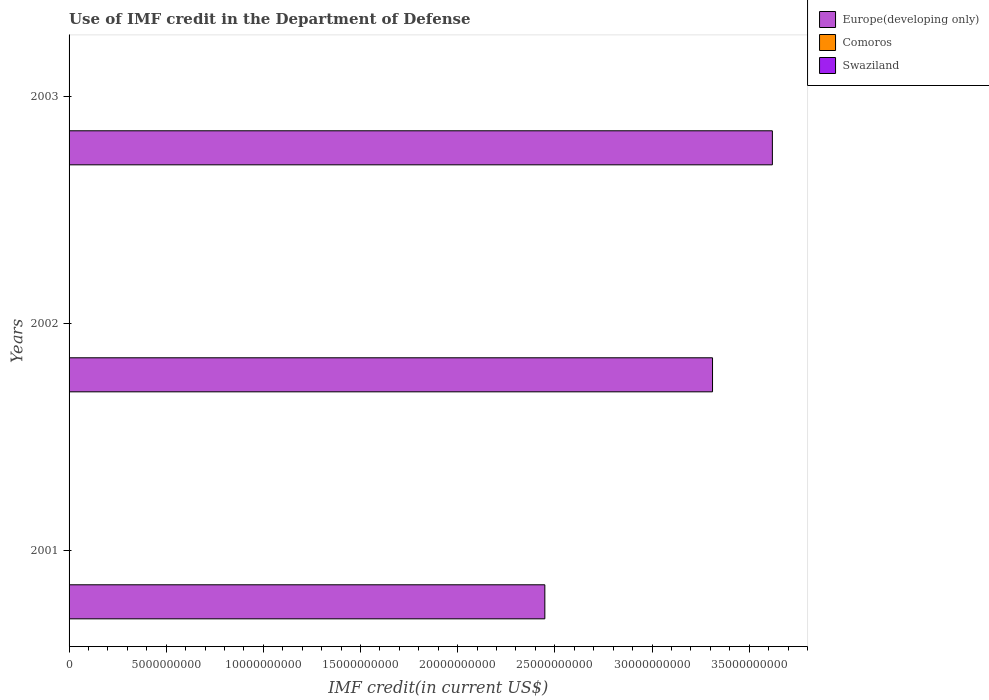How many different coloured bars are there?
Ensure brevity in your answer.  3. Are the number of bars per tick equal to the number of legend labels?
Give a very brief answer. Yes. How many bars are there on the 1st tick from the bottom?
Your answer should be compact. 3. In how many cases, is the number of bars for a given year not equal to the number of legend labels?
Keep it short and to the point. 0. What is the IMF credit in the Department of Defense in Comoros in 2002?
Your answer should be compact. 1.52e+06. Across all years, what is the maximum IMF credit in the Department of Defense in Swaziland?
Give a very brief answer. 9.56e+06. Across all years, what is the minimum IMF credit in the Department of Defense in Swaziland?
Offer a terse response. 8.08e+06. In which year was the IMF credit in the Department of Defense in Europe(developing only) maximum?
Provide a short and direct response. 2003. What is the total IMF credit in the Department of Defense in Europe(developing only) in the graph?
Your response must be concise. 9.38e+1. What is the difference between the IMF credit in the Department of Defense in Europe(developing only) in 2001 and that in 2003?
Offer a terse response. -1.17e+1. What is the difference between the IMF credit in the Department of Defense in Swaziland in 2001 and the IMF credit in the Department of Defense in Europe(developing only) in 2002?
Your answer should be compact. -3.31e+1. What is the average IMF credit in the Department of Defense in Swaziland per year?
Your answer should be very brief. 8.80e+06. In the year 2003, what is the difference between the IMF credit in the Department of Defense in Swaziland and IMF credit in the Department of Defense in Europe(developing only)?
Ensure brevity in your answer.  -3.62e+1. What is the ratio of the IMF credit in the Department of Defense in Europe(developing only) in 2002 to that in 2003?
Provide a short and direct response. 0.91. Is the IMF credit in the Department of Defense in Europe(developing only) in 2001 less than that in 2002?
Your response must be concise. Yes. What is the difference between the highest and the second highest IMF credit in the Department of Defense in Europe(developing only)?
Give a very brief answer. 3.08e+09. What is the difference between the highest and the lowest IMF credit in the Department of Defense in Swaziland?
Your response must be concise. 1.48e+06. What does the 3rd bar from the top in 2003 represents?
Your response must be concise. Europe(developing only). What does the 3rd bar from the bottom in 2001 represents?
Your response must be concise. Swaziland. Is it the case that in every year, the sum of the IMF credit in the Department of Defense in Comoros and IMF credit in the Department of Defense in Swaziland is greater than the IMF credit in the Department of Defense in Europe(developing only)?
Give a very brief answer. No. Are all the bars in the graph horizontal?
Keep it short and to the point. Yes. Are the values on the major ticks of X-axis written in scientific E-notation?
Keep it short and to the point. No. Does the graph contain any zero values?
Ensure brevity in your answer.  No. Does the graph contain grids?
Offer a very short reply. No. Where does the legend appear in the graph?
Offer a terse response. Top right. How many legend labels are there?
Make the answer very short. 3. How are the legend labels stacked?
Make the answer very short. Vertical. What is the title of the graph?
Ensure brevity in your answer.  Use of IMF credit in the Department of Defense. Does "Low income" appear as one of the legend labels in the graph?
Offer a very short reply. No. What is the label or title of the X-axis?
Offer a very short reply. IMF credit(in current US$). What is the label or title of the Y-axis?
Ensure brevity in your answer.  Years. What is the IMF credit(in current US$) of Europe(developing only) in 2001?
Offer a terse response. 2.45e+1. What is the IMF credit(in current US$) in Comoros in 2001?
Give a very brief answer. 1.75e+06. What is the IMF credit(in current US$) of Swaziland in 2001?
Your answer should be very brief. 8.08e+06. What is the IMF credit(in current US$) of Europe(developing only) in 2002?
Keep it short and to the point. 3.31e+1. What is the IMF credit(in current US$) in Comoros in 2002?
Offer a very short reply. 1.52e+06. What is the IMF credit(in current US$) of Swaziland in 2002?
Your answer should be very brief. 8.74e+06. What is the IMF credit(in current US$) of Europe(developing only) in 2003?
Make the answer very short. 3.62e+1. What is the IMF credit(in current US$) in Comoros in 2003?
Your response must be concise. 1.27e+06. What is the IMF credit(in current US$) in Swaziland in 2003?
Provide a succinct answer. 9.56e+06. Across all years, what is the maximum IMF credit(in current US$) in Europe(developing only)?
Ensure brevity in your answer.  3.62e+1. Across all years, what is the maximum IMF credit(in current US$) of Comoros?
Your answer should be very brief. 1.75e+06. Across all years, what is the maximum IMF credit(in current US$) in Swaziland?
Keep it short and to the point. 9.56e+06. Across all years, what is the minimum IMF credit(in current US$) of Europe(developing only)?
Provide a succinct answer. 2.45e+1. Across all years, what is the minimum IMF credit(in current US$) of Comoros?
Provide a short and direct response. 1.27e+06. Across all years, what is the minimum IMF credit(in current US$) of Swaziland?
Offer a very short reply. 8.08e+06. What is the total IMF credit(in current US$) of Europe(developing only) in the graph?
Your response must be concise. 9.38e+1. What is the total IMF credit(in current US$) in Comoros in the graph?
Offer a terse response. 4.54e+06. What is the total IMF credit(in current US$) in Swaziland in the graph?
Ensure brevity in your answer.  2.64e+07. What is the difference between the IMF credit(in current US$) of Europe(developing only) in 2001 and that in 2002?
Give a very brief answer. -8.63e+09. What is the difference between the IMF credit(in current US$) in Comoros in 2001 and that in 2002?
Your response must be concise. 2.23e+05. What is the difference between the IMF credit(in current US$) in Swaziland in 2001 and that in 2002?
Provide a short and direct response. -6.61e+05. What is the difference between the IMF credit(in current US$) in Europe(developing only) in 2001 and that in 2003?
Provide a short and direct response. -1.17e+1. What is the difference between the IMF credit(in current US$) in Comoros in 2001 and that in 2003?
Make the answer very short. 4.82e+05. What is the difference between the IMF credit(in current US$) in Swaziland in 2001 and that in 2003?
Provide a short and direct response. -1.48e+06. What is the difference between the IMF credit(in current US$) of Europe(developing only) in 2002 and that in 2003?
Keep it short and to the point. -3.08e+09. What is the difference between the IMF credit(in current US$) of Comoros in 2002 and that in 2003?
Your answer should be very brief. 2.59e+05. What is the difference between the IMF credit(in current US$) of Swaziland in 2002 and that in 2003?
Your response must be concise. -8.14e+05. What is the difference between the IMF credit(in current US$) in Europe(developing only) in 2001 and the IMF credit(in current US$) in Comoros in 2002?
Provide a succinct answer. 2.45e+1. What is the difference between the IMF credit(in current US$) of Europe(developing only) in 2001 and the IMF credit(in current US$) of Swaziland in 2002?
Ensure brevity in your answer.  2.45e+1. What is the difference between the IMF credit(in current US$) of Comoros in 2001 and the IMF credit(in current US$) of Swaziland in 2002?
Your answer should be very brief. -7.00e+06. What is the difference between the IMF credit(in current US$) in Europe(developing only) in 2001 and the IMF credit(in current US$) in Comoros in 2003?
Offer a terse response. 2.45e+1. What is the difference between the IMF credit(in current US$) in Europe(developing only) in 2001 and the IMF credit(in current US$) in Swaziland in 2003?
Provide a short and direct response. 2.45e+1. What is the difference between the IMF credit(in current US$) of Comoros in 2001 and the IMF credit(in current US$) of Swaziland in 2003?
Your response must be concise. -7.81e+06. What is the difference between the IMF credit(in current US$) in Europe(developing only) in 2002 and the IMF credit(in current US$) in Comoros in 2003?
Give a very brief answer. 3.31e+1. What is the difference between the IMF credit(in current US$) of Europe(developing only) in 2002 and the IMF credit(in current US$) of Swaziland in 2003?
Provide a short and direct response. 3.31e+1. What is the difference between the IMF credit(in current US$) in Comoros in 2002 and the IMF credit(in current US$) in Swaziland in 2003?
Give a very brief answer. -8.03e+06. What is the average IMF credit(in current US$) of Europe(developing only) per year?
Your answer should be very brief. 3.13e+1. What is the average IMF credit(in current US$) in Comoros per year?
Ensure brevity in your answer.  1.51e+06. What is the average IMF credit(in current US$) in Swaziland per year?
Your answer should be very brief. 8.80e+06. In the year 2001, what is the difference between the IMF credit(in current US$) of Europe(developing only) and IMF credit(in current US$) of Comoros?
Provide a short and direct response. 2.45e+1. In the year 2001, what is the difference between the IMF credit(in current US$) of Europe(developing only) and IMF credit(in current US$) of Swaziland?
Provide a succinct answer. 2.45e+1. In the year 2001, what is the difference between the IMF credit(in current US$) of Comoros and IMF credit(in current US$) of Swaziland?
Provide a succinct answer. -6.34e+06. In the year 2002, what is the difference between the IMF credit(in current US$) of Europe(developing only) and IMF credit(in current US$) of Comoros?
Offer a terse response. 3.31e+1. In the year 2002, what is the difference between the IMF credit(in current US$) of Europe(developing only) and IMF credit(in current US$) of Swaziland?
Keep it short and to the point. 3.31e+1. In the year 2002, what is the difference between the IMF credit(in current US$) in Comoros and IMF credit(in current US$) in Swaziland?
Provide a short and direct response. -7.22e+06. In the year 2003, what is the difference between the IMF credit(in current US$) of Europe(developing only) and IMF credit(in current US$) of Comoros?
Your response must be concise. 3.62e+1. In the year 2003, what is the difference between the IMF credit(in current US$) in Europe(developing only) and IMF credit(in current US$) in Swaziland?
Make the answer very short. 3.62e+1. In the year 2003, what is the difference between the IMF credit(in current US$) of Comoros and IMF credit(in current US$) of Swaziland?
Offer a terse response. -8.29e+06. What is the ratio of the IMF credit(in current US$) of Europe(developing only) in 2001 to that in 2002?
Provide a succinct answer. 0.74. What is the ratio of the IMF credit(in current US$) in Comoros in 2001 to that in 2002?
Keep it short and to the point. 1.15. What is the ratio of the IMF credit(in current US$) in Swaziland in 2001 to that in 2002?
Provide a short and direct response. 0.92. What is the ratio of the IMF credit(in current US$) of Europe(developing only) in 2001 to that in 2003?
Keep it short and to the point. 0.68. What is the ratio of the IMF credit(in current US$) of Comoros in 2001 to that in 2003?
Provide a succinct answer. 1.38. What is the ratio of the IMF credit(in current US$) in Swaziland in 2001 to that in 2003?
Provide a short and direct response. 0.85. What is the ratio of the IMF credit(in current US$) in Europe(developing only) in 2002 to that in 2003?
Keep it short and to the point. 0.91. What is the ratio of the IMF credit(in current US$) of Comoros in 2002 to that in 2003?
Your answer should be very brief. 1.2. What is the ratio of the IMF credit(in current US$) in Swaziland in 2002 to that in 2003?
Your answer should be very brief. 0.91. What is the difference between the highest and the second highest IMF credit(in current US$) of Europe(developing only)?
Your answer should be compact. 3.08e+09. What is the difference between the highest and the second highest IMF credit(in current US$) in Comoros?
Your answer should be very brief. 2.23e+05. What is the difference between the highest and the second highest IMF credit(in current US$) in Swaziland?
Keep it short and to the point. 8.14e+05. What is the difference between the highest and the lowest IMF credit(in current US$) of Europe(developing only)?
Your response must be concise. 1.17e+1. What is the difference between the highest and the lowest IMF credit(in current US$) of Comoros?
Your answer should be very brief. 4.82e+05. What is the difference between the highest and the lowest IMF credit(in current US$) in Swaziland?
Your answer should be compact. 1.48e+06. 